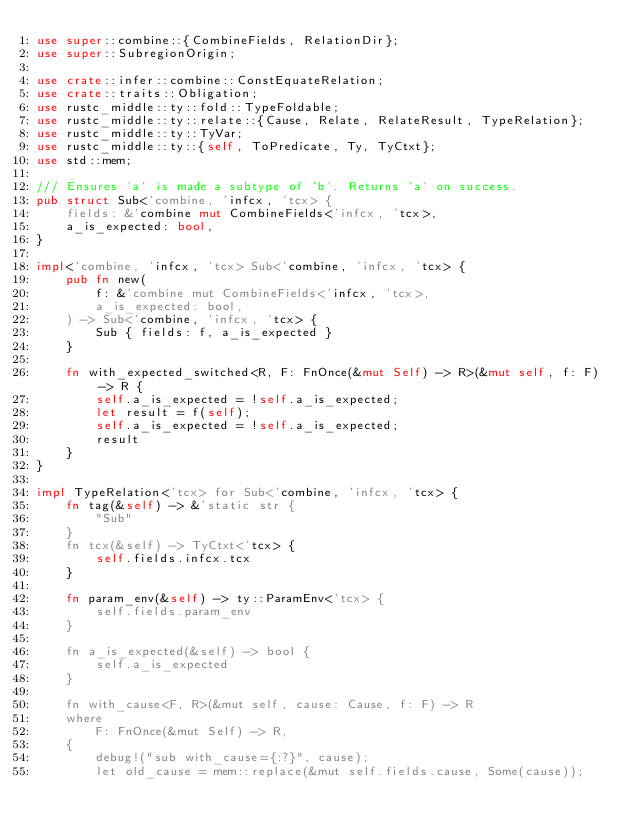Convert code to text. <code><loc_0><loc_0><loc_500><loc_500><_Rust_>use super::combine::{CombineFields, RelationDir};
use super::SubregionOrigin;

use crate::infer::combine::ConstEquateRelation;
use crate::traits::Obligation;
use rustc_middle::ty::fold::TypeFoldable;
use rustc_middle::ty::relate::{Cause, Relate, RelateResult, TypeRelation};
use rustc_middle::ty::TyVar;
use rustc_middle::ty::{self, ToPredicate, Ty, TyCtxt};
use std::mem;

/// Ensures `a` is made a subtype of `b`. Returns `a` on success.
pub struct Sub<'combine, 'infcx, 'tcx> {
    fields: &'combine mut CombineFields<'infcx, 'tcx>,
    a_is_expected: bool,
}

impl<'combine, 'infcx, 'tcx> Sub<'combine, 'infcx, 'tcx> {
    pub fn new(
        f: &'combine mut CombineFields<'infcx, 'tcx>,
        a_is_expected: bool,
    ) -> Sub<'combine, 'infcx, 'tcx> {
        Sub { fields: f, a_is_expected }
    }

    fn with_expected_switched<R, F: FnOnce(&mut Self) -> R>(&mut self, f: F) -> R {
        self.a_is_expected = !self.a_is_expected;
        let result = f(self);
        self.a_is_expected = !self.a_is_expected;
        result
    }
}

impl TypeRelation<'tcx> for Sub<'combine, 'infcx, 'tcx> {
    fn tag(&self) -> &'static str {
        "Sub"
    }
    fn tcx(&self) -> TyCtxt<'tcx> {
        self.fields.infcx.tcx
    }

    fn param_env(&self) -> ty::ParamEnv<'tcx> {
        self.fields.param_env
    }

    fn a_is_expected(&self) -> bool {
        self.a_is_expected
    }

    fn with_cause<F, R>(&mut self, cause: Cause, f: F) -> R
    where
        F: FnOnce(&mut Self) -> R,
    {
        debug!("sub with_cause={:?}", cause);
        let old_cause = mem::replace(&mut self.fields.cause, Some(cause));</code> 